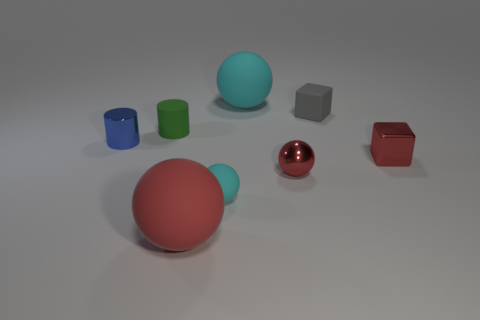Add 2 matte spheres. How many objects exist? 10 Subtract all cubes. How many objects are left? 6 Add 7 big brown matte balls. How many big brown matte balls exist? 7 Subtract 1 red blocks. How many objects are left? 7 Subtract all red rubber things. Subtract all tiny brown balls. How many objects are left? 7 Add 2 tiny matte cylinders. How many tiny matte cylinders are left? 3 